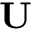<formula> <loc_0><loc_0><loc_500><loc_500>U</formula> 